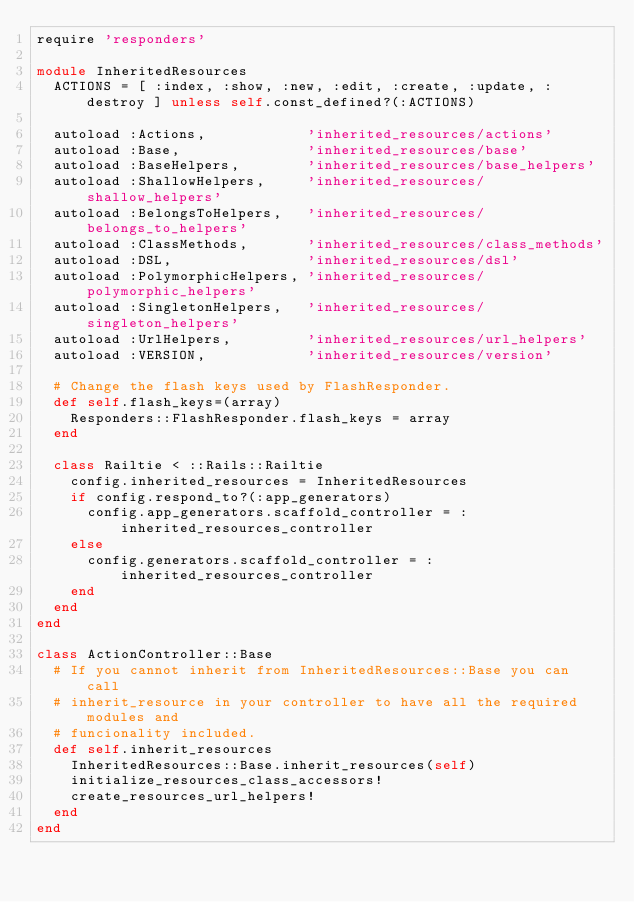<code> <loc_0><loc_0><loc_500><loc_500><_Ruby_>require 'responders'

module InheritedResources
  ACTIONS = [ :index, :show, :new, :edit, :create, :update, :destroy ] unless self.const_defined?(:ACTIONS)

  autoload :Actions,            'inherited_resources/actions'
  autoload :Base,               'inherited_resources/base'
  autoload :BaseHelpers,        'inherited_resources/base_helpers'
  autoload :ShallowHelpers,     'inherited_resources/shallow_helpers'
  autoload :BelongsToHelpers,   'inherited_resources/belongs_to_helpers'
  autoload :ClassMethods,       'inherited_resources/class_methods'
  autoload :DSL,                'inherited_resources/dsl'
  autoload :PolymorphicHelpers, 'inherited_resources/polymorphic_helpers'
  autoload :SingletonHelpers,   'inherited_resources/singleton_helpers'
  autoload :UrlHelpers,         'inherited_resources/url_helpers'
  autoload :VERSION,            'inherited_resources/version'

  # Change the flash keys used by FlashResponder.
  def self.flash_keys=(array)
    Responders::FlashResponder.flash_keys = array
  end

  class Railtie < ::Rails::Railtie
    config.inherited_resources = InheritedResources
    if config.respond_to?(:app_generators)
      config.app_generators.scaffold_controller = :inherited_resources_controller
    else
      config.generators.scaffold_controller = :inherited_resources_controller
    end
  end
end

class ActionController::Base
  # If you cannot inherit from InheritedResources::Base you can call
  # inherit_resource in your controller to have all the required modules and
  # funcionality included.
  def self.inherit_resources
    InheritedResources::Base.inherit_resources(self)
    initialize_resources_class_accessors!
    create_resources_url_helpers!
  end
end
</code> 